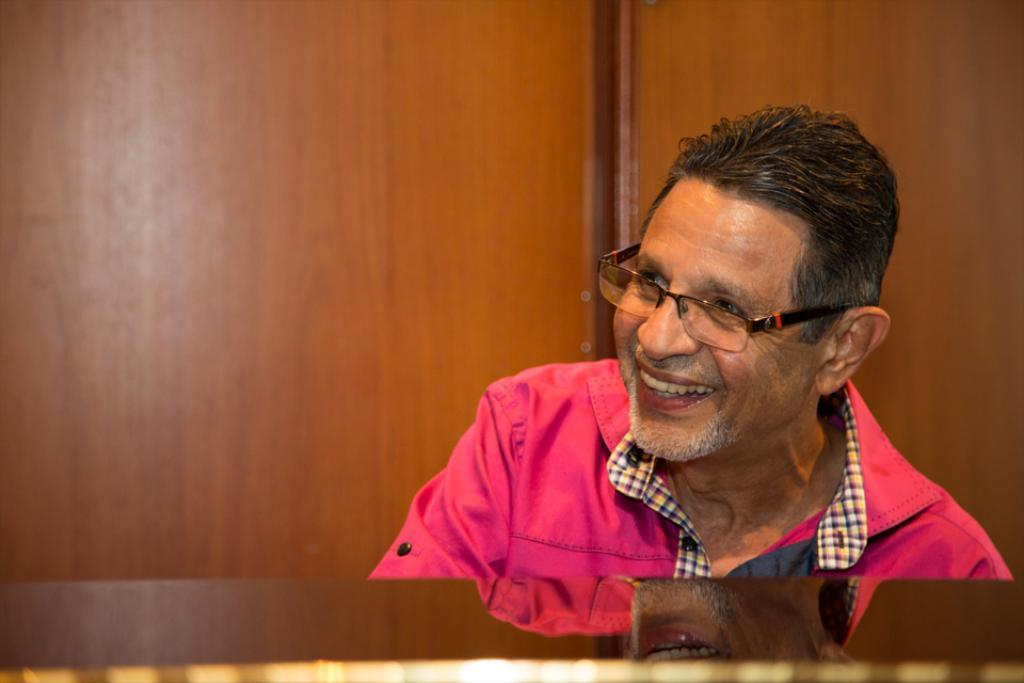Who is present in the image? There is a man in the image. What is the man doing in the image? The man is smiling in the image. What accessory is the man wearing in the image? The man is wearing spectacles in the image. What type of background is visible in the image? There is a wooden background in the image. What type of sugar is being used to sweeten the kettle in the image? There is no sugar or kettle present in the image; it features a man smiling with spectacles in front of a wooden background. 